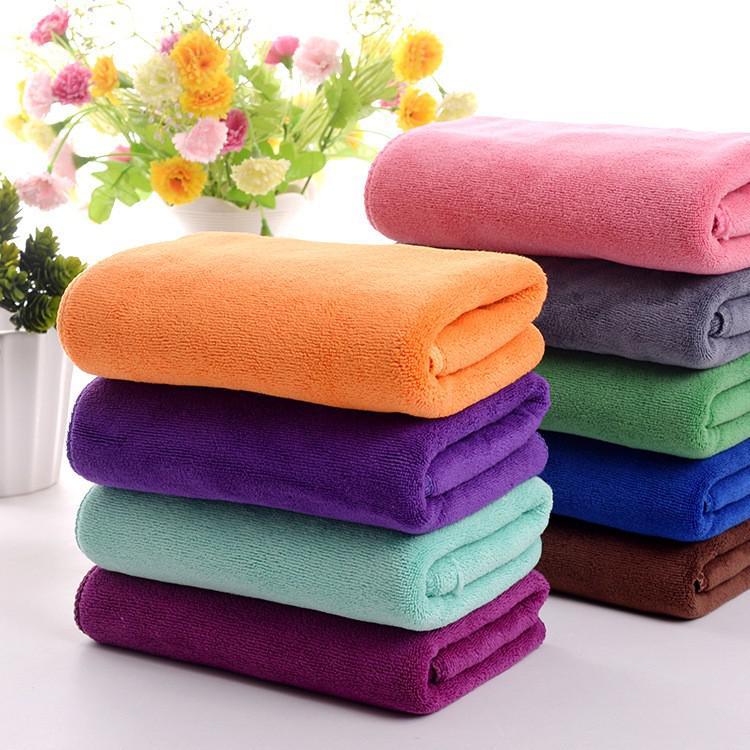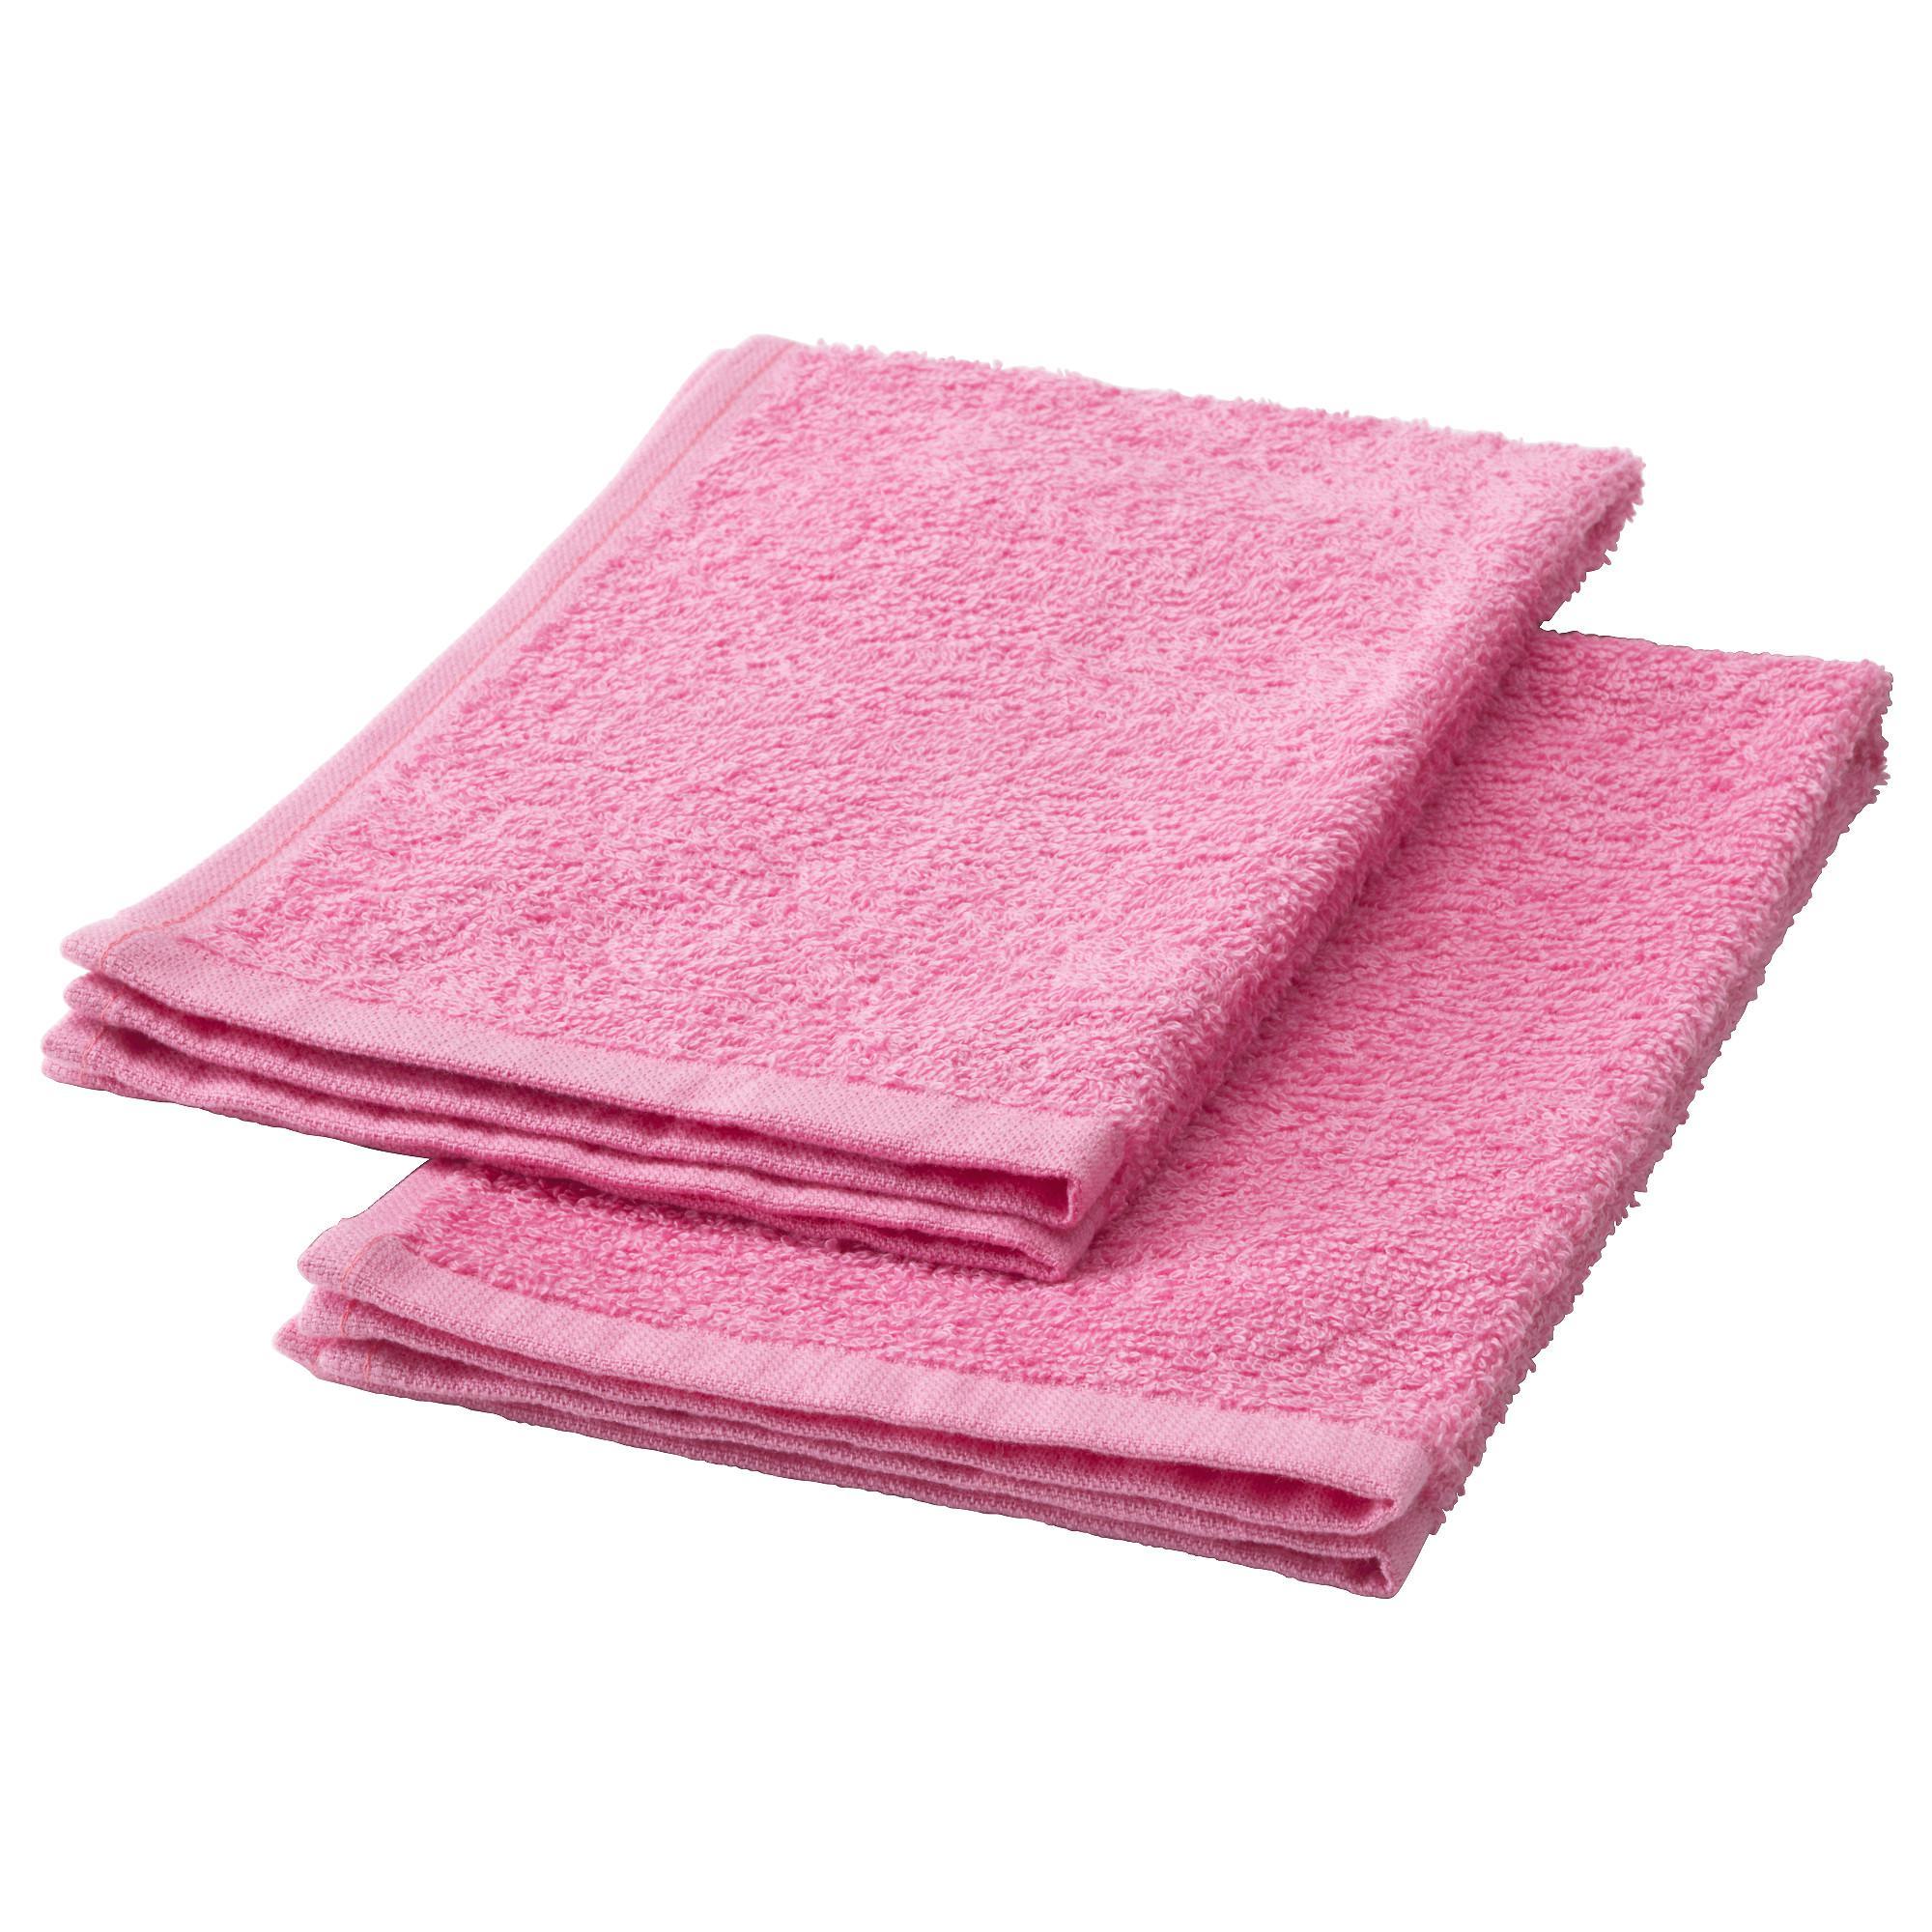The first image is the image on the left, the second image is the image on the right. Evaluate the accuracy of this statement regarding the images: "In the image on the left the there is an orange towel at the top of a stack of towels.". Is it true? Answer yes or no. Yes. The first image is the image on the left, the second image is the image on the right. Given the left and right images, does the statement "In one image, a pink towel is draped over and around a single stack of seven or fewer folded towels in various colors." hold true? Answer yes or no. No. 